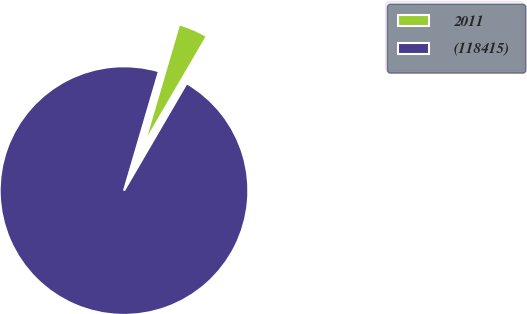<chart> <loc_0><loc_0><loc_500><loc_500><pie_chart><fcel>2011<fcel>(118415)<nl><fcel>3.87%<fcel>96.13%<nl></chart> 